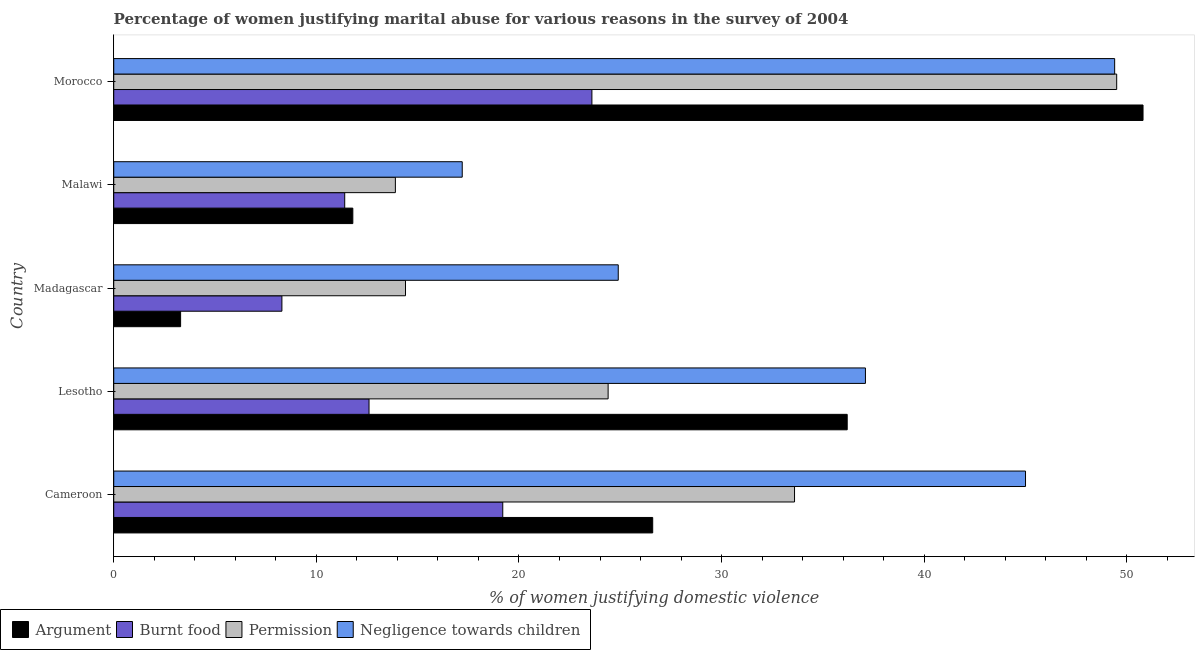Are the number of bars per tick equal to the number of legend labels?
Offer a terse response. Yes. Are the number of bars on each tick of the Y-axis equal?
Keep it short and to the point. Yes. How many bars are there on the 1st tick from the bottom?
Your response must be concise. 4. What is the label of the 5th group of bars from the top?
Ensure brevity in your answer.  Cameroon. In how many cases, is the number of bars for a given country not equal to the number of legend labels?
Your response must be concise. 0. Across all countries, what is the maximum percentage of women justifying abuse in the case of an argument?
Keep it short and to the point. 50.8. Across all countries, what is the minimum percentage of women justifying abuse for showing negligence towards children?
Provide a succinct answer. 17.2. In which country was the percentage of women justifying abuse for showing negligence towards children maximum?
Provide a short and direct response. Morocco. In which country was the percentage of women justifying abuse in the case of an argument minimum?
Make the answer very short. Madagascar. What is the total percentage of women justifying abuse for going without permission in the graph?
Ensure brevity in your answer.  135.8. What is the difference between the percentage of women justifying abuse in the case of an argument in Lesotho and that in Morocco?
Offer a terse response. -14.6. What is the average percentage of women justifying abuse for going without permission per country?
Ensure brevity in your answer.  27.16. What is the ratio of the percentage of women justifying abuse for going without permission in Cameroon to that in Lesotho?
Make the answer very short. 1.38. Is the difference between the percentage of women justifying abuse for going without permission in Madagascar and Morocco greater than the difference between the percentage of women justifying abuse in the case of an argument in Madagascar and Morocco?
Make the answer very short. Yes. What is the difference between the highest and the lowest percentage of women justifying abuse for going without permission?
Keep it short and to the point. 35.6. Is the sum of the percentage of women justifying abuse for burning food in Lesotho and Morocco greater than the maximum percentage of women justifying abuse for going without permission across all countries?
Your response must be concise. No. What does the 2nd bar from the top in Lesotho represents?
Your answer should be compact. Permission. What does the 2nd bar from the bottom in Malawi represents?
Your answer should be compact. Burnt food. How many bars are there?
Provide a short and direct response. 20. Are all the bars in the graph horizontal?
Give a very brief answer. Yes. Does the graph contain any zero values?
Ensure brevity in your answer.  No. Where does the legend appear in the graph?
Provide a succinct answer. Bottom left. How are the legend labels stacked?
Keep it short and to the point. Horizontal. What is the title of the graph?
Your answer should be very brief. Percentage of women justifying marital abuse for various reasons in the survey of 2004. Does "UNAIDS" appear as one of the legend labels in the graph?
Your response must be concise. No. What is the label or title of the X-axis?
Offer a very short reply. % of women justifying domestic violence. What is the label or title of the Y-axis?
Your response must be concise. Country. What is the % of women justifying domestic violence of Argument in Cameroon?
Keep it short and to the point. 26.6. What is the % of women justifying domestic violence in Permission in Cameroon?
Provide a short and direct response. 33.6. What is the % of women justifying domestic violence in Negligence towards children in Cameroon?
Provide a short and direct response. 45. What is the % of women justifying domestic violence in Argument in Lesotho?
Make the answer very short. 36.2. What is the % of women justifying domestic violence in Permission in Lesotho?
Your answer should be very brief. 24.4. What is the % of women justifying domestic violence in Negligence towards children in Lesotho?
Offer a very short reply. 37.1. What is the % of women justifying domestic violence of Negligence towards children in Madagascar?
Ensure brevity in your answer.  24.9. What is the % of women justifying domestic violence in Argument in Morocco?
Offer a very short reply. 50.8. What is the % of women justifying domestic violence of Burnt food in Morocco?
Your answer should be very brief. 23.6. What is the % of women justifying domestic violence in Permission in Morocco?
Your answer should be compact. 49.5. What is the % of women justifying domestic violence of Negligence towards children in Morocco?
Give a very brief answer. 49.4. Across all countries, what is the maximum % of women justifying domestic violence in Argument?
Your response must be concise. 50.8. Across all countries, what is the maximum % of women justifying domestic violence in Burnt food?
Your response must be concise. 23.6. Across all countries, what is the maximum % of women justifying domestic violence in Permission?
Ensure brevity in your answer.  49.5. Across all countries, what is the maximum % of women justifying domestic violence in Negligence towards children?
Make the answer very short. 49.4. Across all countries, what is the minimum % of women justifying domestic violence in Argument?
Give a very brief answer. 3.3. Across all countries, what is the minimum % of women justifying domestic violence in Permission?
Offer a terse response. 13.9. Across all countries, what is the minimum % of women justifying domestic violence in Negligence towards children?
Make the answer very short. 17.2. What is the total % of women justifying domestic violence of Argument in the graph?
Offer a very short reply. 128.7. What is the total % of women justifying domestic violence of Burnt food in the graph?
Give a very brief answer. 75.1. What is the total % of women justifying domestic violence of Permission in the graph?
Your response must be concise. 135.8. What is the total % of women justifying domestic violence of Negligence towards children in the graph?
Ensure brevity in your answer.  173.6. What is the difference between the % of women justifying domestic violence of Negligence towards children in Cameroon and that in Lesotho?
Your answer should be compact. 7.9. What is the difference between the % of women justifying domestic violence in Argument in Cameroon and that in Madagascar?
Give a very brief answer. 23.3. What is the difference between the % of women justifying domestic violence of Permission in Cameroon and that in Madagascar?
Your response must be concise. 19.2. What is the difference between the % of women justifying domestic violence in Negligence towards children in Cameroon and that in Madagascar?
Give a very brief answer. 20.1. What is the difference between the % of women justifying domestic violence in Permission in Cameroon and that in Malawi?
Your response must be concise. 19.7. What is the difference between the % of women justifying domestic violence in Negligence towards children in Cameroon and that in Malawi?
Provide a succinct answer. 27.8. What is the difference between the % of women justifying domestic violence of Argument in Cameroon and that in Morocco?
Provide a succinct answer. -24.2. What is the difference between the % of women justifying domestic violence in Burnt food in Cameroon and that in Morocco?
Your answer should be very brief. -4.4. What is the difference between the % of women justifying domestic violence in Permission in Cameroon and that in Morocco?
Your answer should be very brief. -15.9. What is the difference between the % of women justifying domestic violence in Negligence towards children in Cameroon and that in Morocco?
Make the answer very short. -4.4. What is the difference between the % of women justifying domestic violence in Argument in Lesotho and that in Madagascar?
Your response must be concise. 32.9. What is the difference between the % of women justifying domestic violence in Burnt food in Lesotho and that in Madagascar?
Keep it short and to the point. 4.3. What is the difference between the % of women justifying domestic violence in Argument in Lesotho and that in Malawi?
Ensure brevity in your answer.  24.4. What is the difference between the % of women justifying domestic violence in Permission in Lesotho and that in Malawi?
Your response must be concise. 10.5. What is the difference between the % of women justifying domestic violence in Argument in Lesotho and that in Morocco?
Ensure brevity in your answer.  -14.6. What is the difference between the % of women justifying domestic violence of Burnt food in Lesotho and that in Morocco?
Ensure brevity in your answer.  -11. What is the difference between the % of women justifying domestic violence of Permission in Lesotho and that in Morocco?
Offer a terse response. -25.1. What is the difference between the % of women justifying domestic violence of Argument in Madagascar and that in Malawi?
Provide a short and direct response. -8.5. What is the difference between the % of women justifying domestic violence in Burnt food in Madagascar and that in Malawi?
Your response must be concise. -3.1. What is the difference between the % of women justifying domestic violence of Permission in Madagascar and that in Malawi?
Offer a very short reply. 0.5. What is the difference between the % of women justifying domestic violence of Negligence towards children in Madagascar and that in Malawi?
Give a very brief answer. 7.7. What is the difference between the % of women justifying domestic violence of Argument in Madagascar and that in Morocco?
Make the answer very short. -47.5. What is the difference between the % of women justifying domestic violence in Burnt food in Madagascar and that in Morocco?
Keep it short and to the point. -15.3. What is the difference between the % of women justifying domestic violence in Permission in Madagascar and that in Morocco?
Keep it short and to the point. -35.1. What is the difference between the % of women justifying domestic violence in Negligence towards children in Madagascar and that in Morocco?
Offer a very short reply. -24.5. What is the difference between the % of women justifying domestic violence in Argument in Malawi and that in Morocco?
Ensure brevity in your answer.  -39. What is the difference between the % of women justifying domestic violence of Permission in Malawi and that in Morocco?
Keep it short and to the point. -35.6. What is the difference between the % of women justifying domestic violence in Negligence towards children in Malawi and that in Morocco?
Your answer should be very brief. -32.2. What is the difference between the % of women justifying domestic violence in Argument in Cameroon and the % of women justifying domestic violence in Permission in Lesotho?
Keep it short and to the point. 2.2. What is the difference between the % of women justifying domestic violence in Burnt food in Cameroon and the % of women justifying domestic violence in Negligence towards children in Lesotho?
Ensure brevity in your answer.  -17.9. What is the difference between the % of women justifying domestic violence in Permission in Cameroon and the % of women justifying domestic violence in Negligence towards children in Lesotho?
Your response must be concise. -3.5. What is the difference between the % of women justifying domestic violence of Argument in Cameroon and the % of women justifying domestic violence of Permission in Madagascar?
Make the answer very short. 12.2. What is the difference between the % of women justifying domestic violence in Argument in Cameroon and the % of women justifying domestic violence in Negligence towards children in Madagascar?
Your response must be concise. 1.7. What is the difference between the % of women justifying domestic violence of Burnt food in Cameroon and the % of women justifying domestic violence of Negligence towards children in Madagascar?
Your answer should be very brief. -5.7. What is the difference between the % of women justifying domestic violence in Argument in Cameroon and the % of women justifying domestic violence in Burnt food in Malawi?
Your response must be concise. 15.2. What is the difference between the % of women justifying domestic violence in Argument in Cameroon and the % of women justifying domestic violence in Permission in Malawi?
Ensure brevity in your answer.  12.7. What is the difference between the % of women justifying domestic violence in Argument in Cameroon and the % of women justifying domestic violence in Negligence towards children in Malawi?
Your answer should be very brief. 9.4. What is the difference between the % of women justifying domestic violence of Burnt food in Cameroon and the % of women justifying domestic violence of Permission in Malawi?
Provide a succinct answer. 5.3. What is the difference between the % of women justifying domestic violence of Permission in Cameroon and the % of women justifying domestic violence of Negligence towards children in Malawi?
Your answer should be compact. 16.4. What is the difference between the % of women justifying domestic violence in Argument in Cameroon and the % of women justifying domestic violence in Permission in Morocco?
Ensure brevity in your answer.  -22.9. What is the difference between the % of women justifying domestic violence in Argument in Cameroon and the % of women justifying domestic violence in Negligence towards children in Morocco?
Offer a terse response. -22.8. What is the difference between the % of women justifying domestic violence of Burnt food in Cameroon and the % of women justifying domestic violence of Permission in Morocco?
Keep it short and to the point. -30.3. What is the difference between the % of women justifying domestic violence of Burnt food in Cameroon and the % of women justifying domestic violence of Negligence towards children in Morocco?
Make the answer very short. -30.2. What is the difference between the % of women justifying domestic violence in Permission in Cameroon and the % of women justifying domestic violence in Negligence towards children in Morocco?
Your response must be concise. -15.8. What is the difference between the % of women justifying domestic violence of Argument in Lesotho and the % of women justifying domestic violence of Burnt food in Madagascar?
Your response must be concise. 27.9. What is the difference between the % of women justifying domestic violence of Argument in Lesotho and the % of women justifying domestic violence of Permission in Madagascar?
Your response must be concise. 21.8. What is the difference between the % of women justifying domestic violence in Burnt food in Lesotho and the % of women justifying domestic violence in Permission in Madagascar?
Keep it short and to the point. -1.8. What is the difference between the % of women justifying domestic violence in Burnt food in Lesotho and the % of women justifying domestic violence in Negligence towards children in Madagascar?
Your answer should be very brief. -12.3. What is the difference between the % of women justifying domestic violence of Permission in Lesotho and the % of women justifying domestic violence of Negligence towards children in Madagascar?
Ensure brevity in your answer.  -0.5. What is the difference between the % of women justifying domestic violence of Argument in Lesotho and the % of women justifying domestic violence of Burnt food in Malawi?
Provide a short and direct response. 24.8. What is the difference between the % of women justifying domestic violence of Argument in Lesotho and the % of women justifying domestic violence of Permission in Malawi?
Provide a succinct answer. 22.3. What is the difference between the % of women justifying domestic violence of Argument in Lesotho and the % of women justifying domestic violence of Negligence towards children in Malawi?
Ensure brevity in your answer.  19. What is the difference between the % of women justifying domestic violence of Burnt food in Lesotho and the % of women justifying domestic violence of Permission in Malawi?
Your answer should be compact. -1.3. What is the difference between the % of women justifying domestic violence in Burnt food in Lesotho and the % of women justifying domestic violence in Negligence towards children in Malawi?
Offer a terse response. -4.6. What is the difference between the % of women justifying domestic violence in Argument in Lesotho and the % of women justifying domestic violence in Burnt food in Morocco?
Make the answer very short. 12.6. What is the difference between the % of women justifying domestic violence in Argument in Lesotho and the % of women justifying domestic violence in Permission in Morocco?
Your answer should be compact. -13.3. What is the difference between the % of women justifying domestic violence in Burnt food in Lesotho and the % of women justifying domestic violence in Permission in Morocco?
Your answer should be very brief. -36.9. What is the difference between the % of women justifying domestic violence in Burnt food in Lesotho and the % of women justifying domestic violence in Negligence towards children in Morocco?
Give a very brief answer. -36.8. What is the difference between the % of women justifying domestic violence in Argument in Madagascar and the % of women justifying domestic violence in Burnt food in Malawi?
Your answer should be compact. -8.1. What is the difference between the % of women justifying domestic violence in Argument in Madagascar and the % of women justifying domestic violence in Permission in Malawi?
Offer a very short reply. -10.6. What is the difference between the % of women justifying domestic violence in Burnt food in Madagascar and the % of women justifying domestic violence in Permission in Malawi?
Ensure brevity in your answer.  -5.6. What is the difference between the % of women justifying domestic violence of Argument in Madagascar and the % of women justifying domestic violence of Burnt food in Morocco?
Give a very brief answer. -20.3. What is the difference between the % of women justifying domestic violence in Argument in Madagascar and the % of women justifying domestic violence in Permission in Morocco?
Offer a terse response. -46.2. What is the difference between the % of women justifying domestic violence in Argument in Madagascar and the % of women justifying domestic violence in Negligence towards children in Morocco?
Provide a succinct answer. -46.1. What is the difference between the % of women justifying domestic violence of Burnt food in Madagascar and the % of women justifying domestic violence of Permission in Morocco?
Your response must be concise. -41.2. What is the difference between the % of women justifying domestic violence of Burnt food in Madagascar and the % of women justifying domestic violence of Negligence towards children in Morocco?
Provide a succinct answer. -41.1. What is the difference between the % of women justifying domestic violence in Permission in Madagascar and the % of women justifying domestic violence in Negligence towards children in Morocco?
Offer a very short reply. -35. What is the difference between the % of women justifying domestic violence in Argument in Malawi and the % of women justifying domestic violence in Burnt food in Morocco?
Provide a succinct answer. -11.8. What is the difference between the % of women justifying domestic violence of Argument in Malawi and the % of women justifying domestic violence of Permission in Morocco?
Give a very brief answer. -37.7. What is the difference between the % of women justifying domestic violence of Argument in Malawi and the % of women justifying domestic violence of Negligence towards children in Morocco?
Your answer should be very brief. -37.6. What is the difference between the % of women justifying domestic violence in Burnt food in Malawi and the % of women justifying domestic violence in Permission in Morocco?
Give a very brief answer. -38.1. What is the difference between the % of women justifying domestic violence in Burnt food in Malawi and the % of women justifying domestic violence in Negligence towards children in Morocco?
Ensure brevity in your answer.  -38. What is the difference between the % of women justifying domestic violence in Permission in Malawi and the % of women justifying domestic violence in Negligence towards children in Morocco?
Offer a very short reply. -35.5. What is the average % of women justifying domestic violence of Argument per country?
Your answer should be very brief. 25.74. What is the average % of women justifying domestic violence in Burnt food per country?
Give a very brief answer. 15.02. What is the average % of women justifying domestic violence of Permission per country?
Offer a very short reply. 27.16. What is the average % of women justifying domestic violence of Negligence towards children per country?
Offer a very short reply. 34.72. What is the difference between the % of women justifying domestic violence of Argument and % of women justifying domestic violence of Burnt food in Cameroon?
Your answer should be very brief. 7.4. What is the difference between the % of women justifying domestic violence in Argument and % of women justifying domestic violence in Permission in Cameroon?
Your answer should be compact. -7. What is the difference between the % of women justifying domestic violence of Argument and % of women justifying domestic violence of Negligence towards children in Cameroon?
Offer a terse response. -18.4. What is the difference between the % of women justifying domestic violence in Burnt food and % of women justifying domestic violence in Permission in Cameroon?
Ensure brevity in your answer.  -14.4. What is the difference between the % of women justifying domestic violence of Burnt food and % of women justifying domestic violence of Negligence towards children in Cameroon?
Ensure brevity in your answer.  -25.8. What is the difference between the % of women justifying domestic violence of Argument and % of women justifying domestic violence of Burnt food in Lesotho?
Ensure brevity in your answer.  23.6. What is the difference between the % of women justifying domestic violence of Burnt food and % of women justifying domestic violence of Negligence towards children in Lesotho?
Your answer should be compact. -24.5. What is the difference between the % of women justifying domestic violence in Argument and % of women justifying domestic violence in Permission in Madagascar?
Provide a succinct answer. -11.1. What is the difference between the % of women justifying domestic violence in Argument and % of women justifying domestic violence in Negligence towards children in Madagascar?
Provide a short and direct response. -21.6. What is the difference between the % of women justifying domestic violence of Burnt food and % of women justifying domestic violence of Negligence towards children in Madagascar?
Keep it short and to the point. -16.6. What is the difference between the % of women justifying domestic violence in Permission and % of women justifying domestic violence in Negligence towards children in Madagascar?
Offer a terse response. -10.5. What is the difference between the % of women justifying domestic violence of Argument and % of women justifying domestic violence of Permission in Malawi?
Your answer should be very brief. -2.1. What is the difference between the % of women justifying domestic violence in Argument and % of women justifying domestic violence in Negligence towards children in Malawi?
Give a very brief answer. -5.4. What is the difference between the % of women justifying domestic violence in Burnt food and % of women justifying domestic violence in Permission in Malawi?
Your answer should be compact. -2.5. What is the difference between the % of women justifying domestic violence of Permission and % of women justifying domestic violence of Negligence towards children in Malawi?
Provide a succinct answer. -3.3. What is the difference between the % of women justifying domestic violence in Argument and % of women justifying domestic violence in Burnt food in Morocco?
Provide a succinct answer. 27.2. What is the difference between the % of women justifying domestic violence of Argument and % of women justifying domestic violence of Negligence towards children in Morocco?
Offer a terse response. 1.4. What is the difference between the % of women justifying domestic violence in Burnt food and % of women justifying domestic violence in Permission in Morocco?
Ensure brevity in your answer.  -25.9. What is the difference between the % of women justifying domestic violence of Burnt food and % of women justifying domestic violence of Negligence towards children in Morocco?
Your answer should be very brief. -25.8. What is the difference between the % of women justifying domestic violence in Permission and % of women justifying domestic violence in Negligence towards children in Morocco?
Your answer should be compact. 0.1. What is the ratio of the % of women justifying domestic violence of Argument in Cameroon to that in Lesotho?
Keep it short and to the point. 0.73. What is the ratio of the % of women justifying domestic violence in Burnt food in Cameroon to that in Lesotho?
Make the answer very short. 1.52. What is the ratio of the % of women justifying domestic violence of Permission in Cameroon to that in Lesotho?
Provide a succinct answer. 1.38. What is the ratio of the % of women justifying domestic violence in Negligence towards children in Cameroon to that in Lesotho?
Your answer should be compact. 1.21. What is the ratio of the % of women justifying domestic violence in Argument in Cameroon to that in Madagascar?
Provide a succinct answer. 8.06. What is the ratio of the % of women justifying domestic violence of Burnt food in Cameroon to that in Madagascar?
Offer a terse response. 2.31. What is the ratio of the % of women justifying domestic violence of Permission in Cameroon to that in Madagascar?
Your answer should be very brief. 2.33. What is the ratio of the % of women justifying domestic violence in Negligence towards children in Cameroon to that in Madagascar?
Provide a succinct answer. 1.81. What is the ratio of the % of women justifying domestic violence in Argument in Cameroon to that in Malawi?
Offer a terse response. 2.25. What is the ratio of the % of women justifying domestic violence in Burnt food in Cameroon to that in Malawi?
Give a very brief answer. 1.68. What is the ratio of the % of women justifying domestic violence in Permission in Cameroon to that in Malawi?
Give a very brief answer. 2.42. What is the ratio of the % of women justifying domestic violence in Negligence towards children in Cameroon to that in Malawi?
Provide a succinct answer. 2.62. What is the ratio of the % of women justifying domestic violence of Argument in Cameroon to that in Morocco?
Provide a short and direct response. 0.52. What is the ratio of the % of women justifying domestic violence in Burnt food in Cameroon to that in Morocco?
Make the answer very short. 0.81. What is the ratio of the % of women justifying domestic violence in Permission in Cameroon to that in Morocco?
Your answer should be compact. 0.68. What is the ratio of the % of women justifying domestic violence of Negligence towards children in Cameroon to that in Morocco?
Keep it short and to the point. 0.91. What is the ratio of the % of women justifying domestic violence of Argument in Lesotho to that in Madagascar?
Offer a terse response. 10.97. What is the ratio of the % of women justifying domestic violence of Burnt food in Lesotho to that in Madagascar?
Provide a short and direct response. 1.52. What is the ratio of the % of women justifying domestic violence of Permission in Lesotho to that in Madagascar?
Keep it short and to the point. 1.69. What is the ratio of the % of women justifying domestic violence of Negligence towards children in Lesotho to that in Madagascar?
Offer a very short reply. 1.49. What is the ratio of the % of women justifying domestic violence of Argument in Lesotho to that in Malawi?
Make the answer very short. 3.07. What is the ratio of the % of women justifying domestic violence in Burnt food in Lesotho to that in Malawi?
Your response must be concise. 1.11. What is the ratio of the % of women justifying domestic violence of Permission in Lesotho to that in Malawi?
Offer a terse response. 1.76. What is the ratio of the % of women justifying domestic violence of Negligence towards children in Lesotho to that in Malawi?
Your answer should be compact. 2.16. What is the ratio of the % of women justifying domestic violence in Argument in Lesotho to that in Morocco?
Your answer should be compact. 0.71. What is the ratio of the % of women justifying domestic violence in Burnt food in Lesotho to that in Morocco?
Your response must be concise. 0.53. What is the ratio of the % of women justifying domestic violence in Permission in Lesotho to that in Morocco?
Your response must be concise. 0.49. What is the ratio of the % of women justifying domestic violence of Negligence towards children in Lesotho to that in Morocco?
Your response must be concise. 0.75. What is the ratio of the % of women justifying domestic violence in Argument in Madagascar to that in Malawi?
Provide a short and direct response. 0.28. What is the ratio of the % of women justifying domestic violence of Burnt food in Madagascar to that in Malawi?
Make the answer very short. 0.73. What is the ratio of the % of women justifying domestic violence in Permission in Madagascar to that in Malawi?
Provide a short and direct response. 1.04. What is the ratio of the % of women justifying domestic violence of Negligence towards children in Madagascar to that in Malawi?
Offer a terse response. 1.45. What is the ratio of the % of women justifying domestic violence of Argument in Madagascar to that in Morocco?
Offer a very short reply. 0.07. What is the ratio of the % of women justifying domestic violence in Burnt food in Madagascar to that in Morocco?
Provide a succinct answer. 0.35. What is the ratio of the % of women justifying domestic violence of Permission in Madagascar to that in Morocco?
Keep it short and to the point. 0.29. What is the ratio of the % of women justifying domestic violence of Negligence towards children in Madagascar to that in Morocco?
Your answer should be very brief. 0.5. What is the ratio of the % of women justifying domestic violence in Argument in Malawi to that in Morocco?
Offer a terse response. 0.23. What is the ratio of the % of women justifying domestic violence in Burnt food in Malawi to that in Morocco?
Offer a terse response. 0.48. What is the ratio of the % of women justifying domestic violence in Permission in Malawi to that in Morocco?
Give a very brief answer. 0.28. What is the ratio of the % of women justifying domestic violence of Negligence towards children in Malawi to that in Morocco?
Provide a succinct answer. 0.35. What is the difference between the highest and the second highest % of women justifying domestic violence in Burnt food?
Keep it short and to the point. 4.4. What is the difference between the highest and the second highest % of women justifying domestic violence in Permission?
Make the answer very short. 15.9. What is the difference between the highest and the second highest % of women justifying domestic violence of Negligence towards children?
Provide a short and direct response. 4.4. What is the difference between the highest and the lowest % of women justifying domestic violence in Argument?
Offer a very short reply. 47.5. What is the difference between the highest and the lowest % of women justifying domestic violence in Permission?
Give a very brief answer. 35.6. What is the difference between the highest and the lowest % of women justifying domestic violence of Negligence towards children?
Offer a terse response. 32.2. 